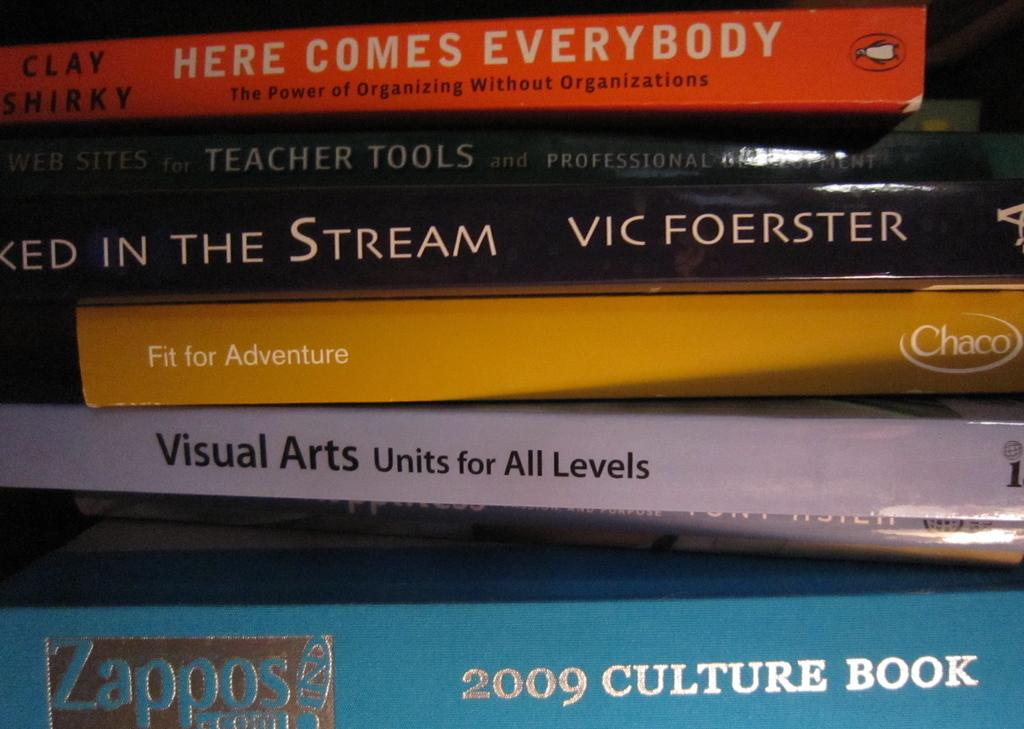<image>
Share a concise interpretation of the image provided. A stack of books with the middle book reading Fit for Adventure. 